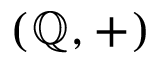Convert formula to latex. <formula><loc_0><loc_0><loc_500><loc_500>( \mathbb { Q } , + )</formula> 